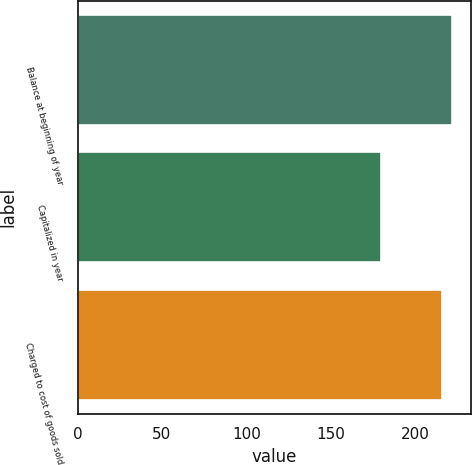Convert chart. <chart><loc_0><loc_0><loc_500><loc_500><bar_chart><fcel>Balance at beginning of year<fcel>Capitalized in year<fcel>Charged to cost of goods sold<nl><fcel>222<fcel>180<fcel>216<nl></chart> 